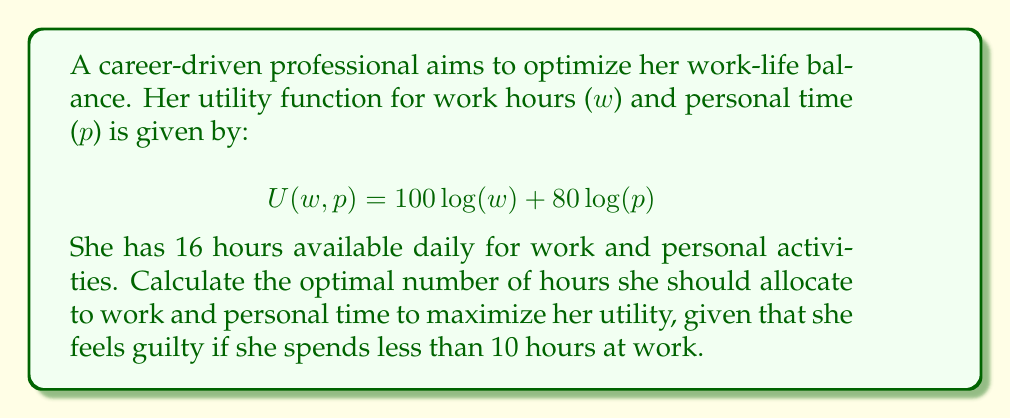Could you help me with this problem? To solve this problem, we'll follow these steps:

1) First, we need to set up the optimization problem:

   Maximize: $U(w,p) = 100\log(w) + 80\log(p)$
   Subject to: $w + p = 16$ and $w \geq 10$

2) Without the guilt constraint ($w \geq 10$), we could solve this using the Lagrange multiplier method. However, given this constraint, we need to check if the unconstrained optimum satisfies it.

3) For the unconstrained optimum:

   $\frac{\partial U}{\partial w} = \frac{100}{w} - \lambda = 0$
   $\frac{\partial U}{\partial p} = \frac{80}{p} - \lambda = 0$

   From these, we can derive: $\frac{100}{w} = \frac{80}{p}$

4) Combining this with the constraint $w + p = 16$, we get:

   $w = \frac{100}{180} * 16 = 8.89$ hours
   $p = \frac{80}{180} * 16 = 7.11$ hours

5) However, this violates the guilt constraint of $w \geq 10$. Therefore, the optimum must occur at the boundary of this constraint.

6) Setting $w = 10$, we can calculate $p$:

   $p = 16 - 10 = 6$

7) Therefore, the optimal allocation is 10 hours for work and 6 hours for personal time.

8) We can verify that this indeed maximizes utility given the constraints by calculating the utility for this allocation:

   $U(10,6) = 100\log(10) + 80\log(6) = 230.28 + 143.55 = 373.83$

   Any other allocation that satisfies the constraints will yield a lower utility.
Answer: The optimal allocation is 10 hours for work and 6 hours for personal time, yielding a maximum utility of approximately 373.83. 